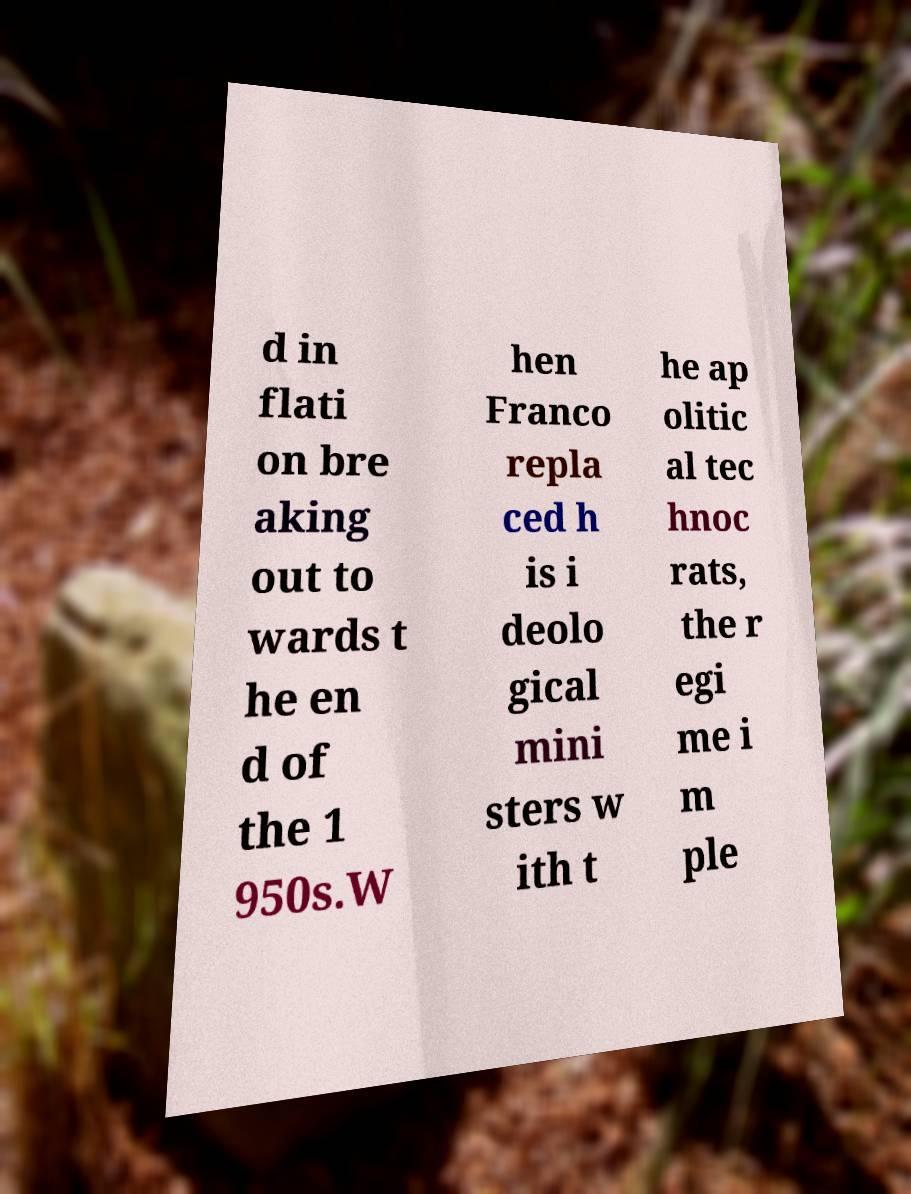Can you read and provide the text displayed in the image?This photo seems to have some interesting text. Can you extract and type it out for me? d in flati on bre aking out to wards t he en d of the 1 950s.W hen Franco repla ced h is i deolo gical mini sters w ith t he ap olitic al tec hnoc rats, the r egi me i m ple 